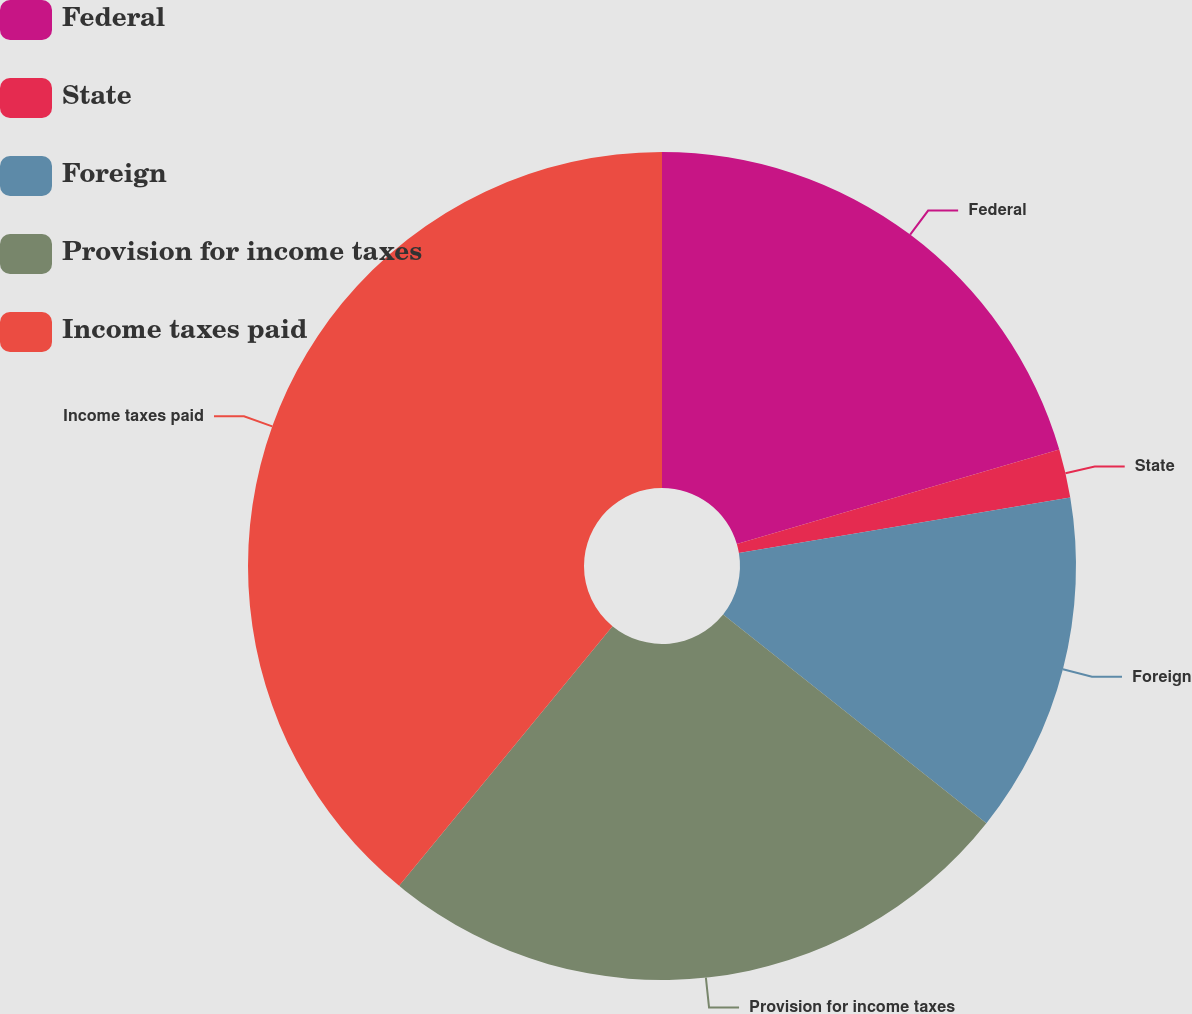<chart> <loc_0><loc_0><loc_500><loc_500><pie_chart><fcel>Federal<fcel>State<fcel>Foreign<fcel>Provision for income taxes<fcel>Income taxes paid<nl><fcel>20.46%<fcel>1.89%<fcel>13.32%<fcel>25.28%<fcel>39.05%<nl></chart> 